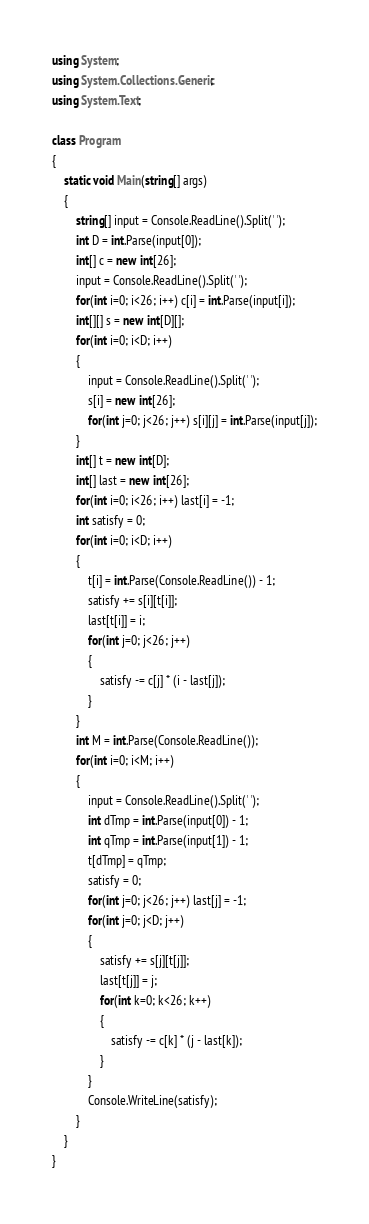<code> <loc_0><loc_0><loc_500><loc_500><_C#_>using System;
using System.Collections.Generic;
using System.Text;

class Program
{
	static void Main(string[] args)
	{
		string[] input = Console.ReadLine().Split(' ');
		int D = int.Parse(input[0]);
		int[] c = new int[26];
		input = Console.ReadLine().Split(' ');
		for(int i=0; i<26; i++) c[i] = int.Parse(input[i]);
		int[][] s = new int[D][];
		for(int i=0; i<D; i++)
		{
			input = Console.ReadLine().Split(' ');
			s[i] = new int[26];
			for(int j=0; j<26; j++) s[i][j] = int.Parse(input[j]);
		}
		int[] t = new int[D];
		int[] last = new int[26];
		for(int i=0; i<26; i++) last[i] = -1;
		int satisfy = 0;
		for(int i=0; i<D; i++)
		{
			t[i] = int.Parse(Console.ReadLine()) - 1;
			satisfy += s[i][t[i]];
			last[t[i]] = i;
			for(int j=0; j<26; j++)
			{
				satisfy -= c[j] * (i - last[j]);
			}
		}
		int M = int.Parse(Console.ReadLine());
		for(int i=0; i<M; i++)
		{
			input = Console.ReadLine().Split(' ');
			int dTmp = int.Parse(input[0]) - 1;
			int qTmp = int.Parse(input[1]) - 1;
			t[dTmp] = qTmp;
			satisfy = 0;
			for(int j=0; j<26; j++) last[j] = -1; 
			for(int j=0; j<D; j++)
			{
				satisfy += s[j][t[j]];
				last[t[j]] = j;
				for(int k=0; k<26; k++)
				{
					satisfy -= c[k] * (j - last[k]);
				}
			}	
			Console.WriteLine(satisfy);	
		}
	}
}
</code> 